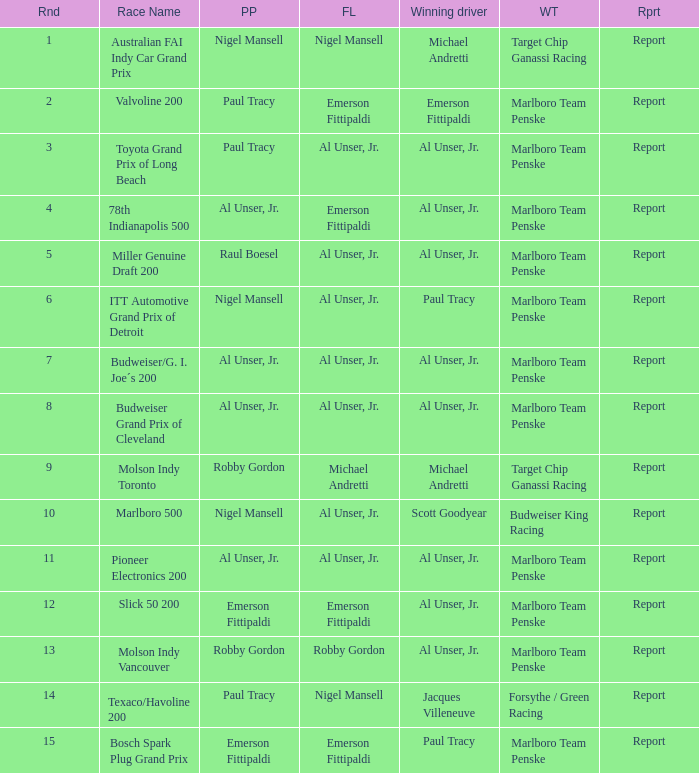What's the report of the race won by Michael Andretti, with Nigel Mansell driving the fastest lap? Report. 